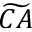Convert formula to latex. <formula><loc_0><loc_0><loc_500><loc_500>\widetilde { C A }</formula> 